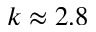Convert formula to latex. <formula><loc_0><loc_0><loc_500><loc_500>k \approx 2 . 8</formula> 